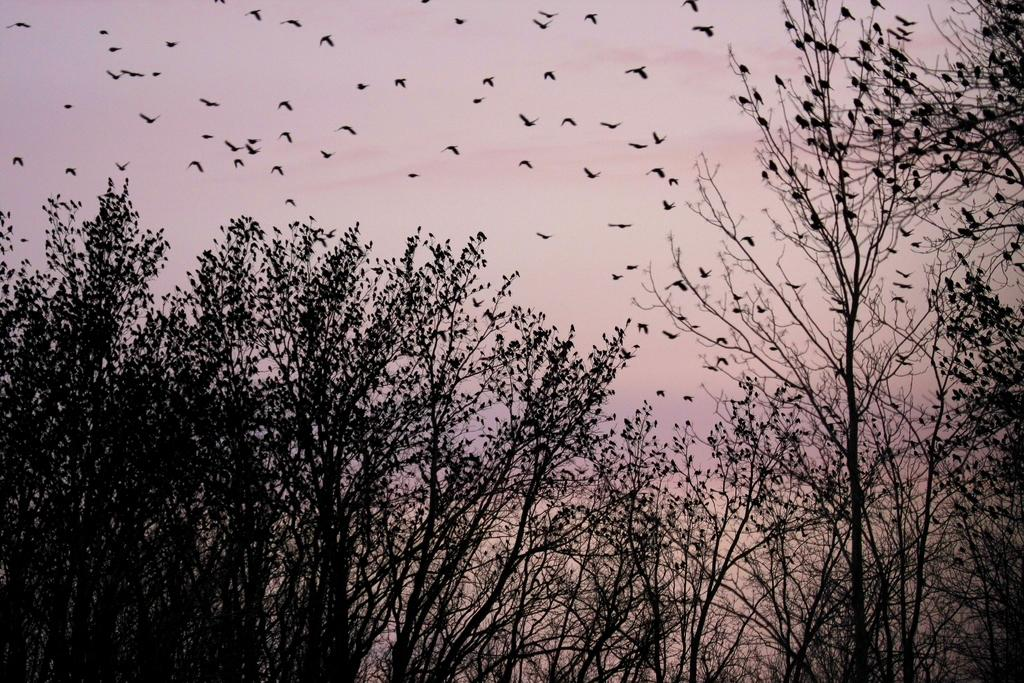What type of animals can be seen in the trees in the image? There are birds on the trees in the image. What are the birds doing in the sky in the image? There are birds flying in the sky in the image. What type of rice can be seen growing near the volcano in the image? There is no volcano or rice present in the image; it features birds on trees and flying in the sky. Is there a fan visible in the image? There is no fan present in the image. 